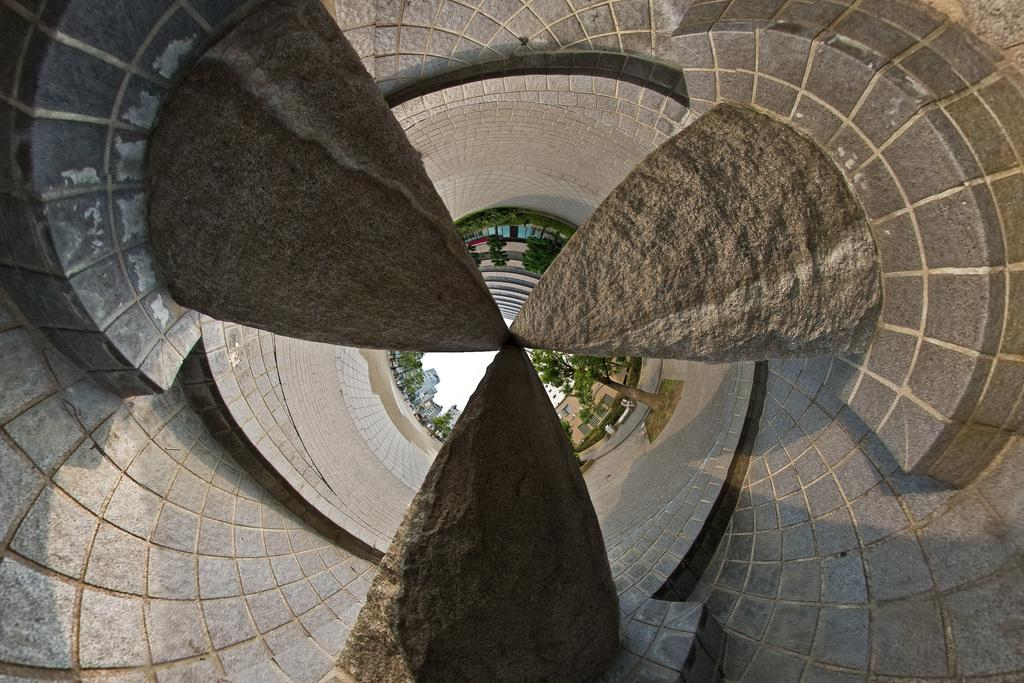What type of architecture can be seen in the image? There is brutalist architecture in the image. What can be seen in the sky in the image? The sky is visible in the image. What type of vegetation is present in the image? There is a tree in the image. What type of structure is depicted in the image? There is a building in the image. What type of car is parked next to the tree in the image? There is no car present in the image; it only features brutalist architecture, the sky, a tree, and a building. What type of poison is being used to treat the tree in the image? There is no mention of poison or any treatment being applied to the tree in the image. 